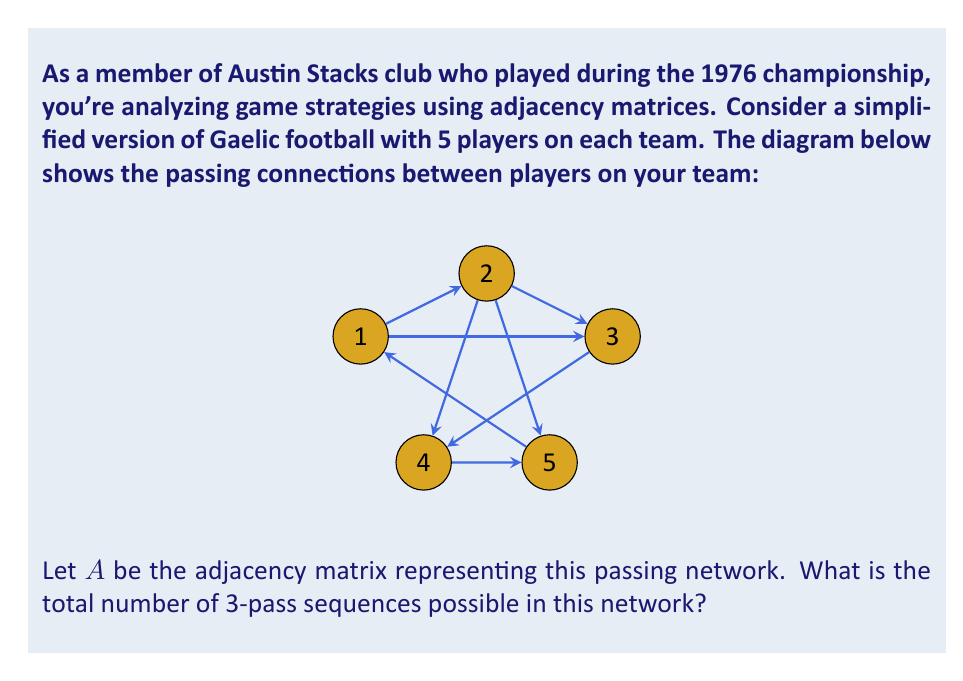Show me your answer to this math problem. Let's approach this step-by-step:

1) First, we need to construct the adjacency matrix $A$ based on the given diagram:

   $$A = \begin{bmatrix}
   0 & 1 & 1 & 1 & 1 \\
   1 & 0 & 1 & 1 & 1 \\
   1 & 1 & 0 & 1 & 1 \\
   1 & 1 & 0 & 0 & 1 \\
   1 & 1 & 1 & 1 & 0
   \end{bmatrix}$$

2) In an adjacency matrix, $A_{ij}$ represents the number of 1-pass sequences from player $i$ to player $j$.

3) To find the number of 2-pass sequences, we need to calculate $A^2$:

   $$A^2 = \begin{bmatrix}
   4 & 3 & 3 & 3 & 3 \\
   3 & 4 & 3 & 3 & 3 \\
   3 & 3 & 4 & 3 & 3 \\
   3 & 3 & 3 & 3 & 2 \\
   3 & 3 & 3 & 2 & 4
   \end{bmatrix}$$

4) Similarly, $A^3$ will give us the number of 3-pass sequences:

   $$A^3 = \begin{bmatrix}
   12 & 13 & 13 & 11 & 13 \\
   13 & 12 & 13 & 11 & 13 \\
   13 & 13 & 12 & 11 & 13 \\
   11 & 11 & 11 & 10 & 10 \\
   13 & 13 & 13 & 10 & 12
   \end{bmatrix}$$

5) The total number of 3-pass sequences is the sum of all entries in $A^3$.

6) Sum of all entries in $A^3 = 12 + 13 + 13 + 11 + 13 + 13 + 12 + 13 + 11 + 13 + 13 + 13 + 12 + 11 + 13 + 11 + 11 + 11 + 10 + 10 + 13 + 13 + 13 + 10 + 12 = 290$
Answer: 290 